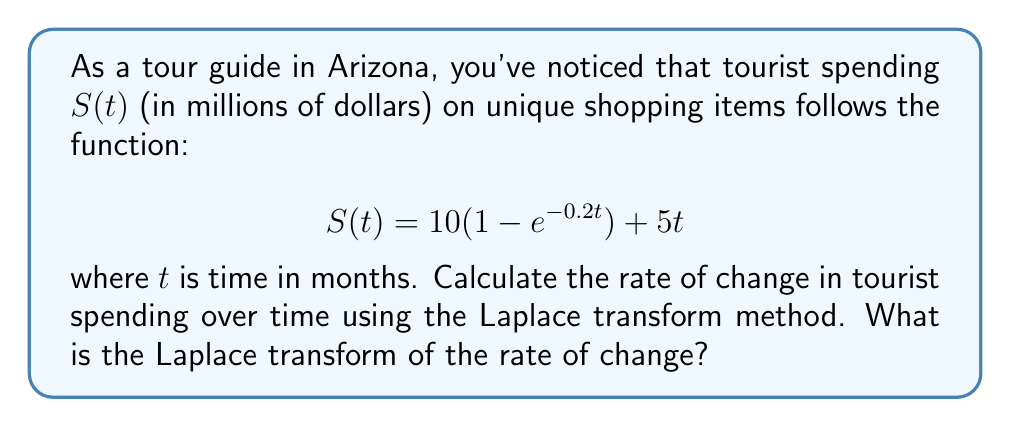Can you answer this question? To solve this problem, we'll follow these steps:

1) First, we need to find the rate of change of $S(t)$, which is its derivative:

   $$\frac{dS}{dt} = 10(0.2e^{-0.2t}) + 5$$

2) Now, we need to find the Laplace transform of this expression. Let's denote the Laplace transform as $\mathcal{L}\{\}$. We'll use the linearity property and standard Laplace transform pairs:

   $$\mathcal{L}\{\frac{dS}{dt}\} = \mathcal{L}\{2e^{-0.2t} + 5\}$$

3) Using the linearity property:

   $$\mathcal{L}\{\frac{dS}{dt}\} = 2\mathcal{L}\{e^{-0.2t}\} + 5\mathcal{L}\{1\}$$

4) We know that:
   - $\mathcal{L}\{e^{-at}\} = \frac{1}{s+a}$
   - $\mathcal{L}\{1\} = \frac{1}{s}$

5) Applying these:

   $$\mathcal{L}\{\frac{dS}{dt}\} = 2\cdot\frac{1}{s+0.2} + 5\cdot\frac{1}{s}$$

6) Simplifying:

   $$\mathcal{L}\{\frac{dS}{dt}\} = \frac{2}{s+0.2} + \frac{5}{s}$$

This is the Laplace transform of the rate of change in tourist spending over time.
Answer: $$\frac{2}{s+0.2} + \frac{5}{s}$$ 